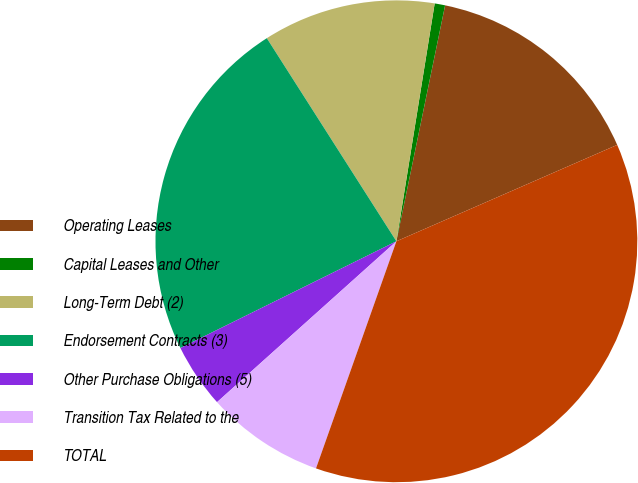Convert chart. <chart><loc_0><loc_0><loc_500><loc_500><pie_chart><fcel>Operating Leases<fcel>Capital Leases and Other<fcel>Long-Term Debt (2)<fcel>Endorsement Contracts (3)<fcel>Other Purchase Obligations (5)<fcel>Transition Tax Related to the<fcel>TOTAL<nl><fcel>15.21%<fcel>0.7%<fcel>11.58%<fcel>23.27%<fcel>4.33%<fcel>7.95%<fcel>36.97%<nl></chart> 